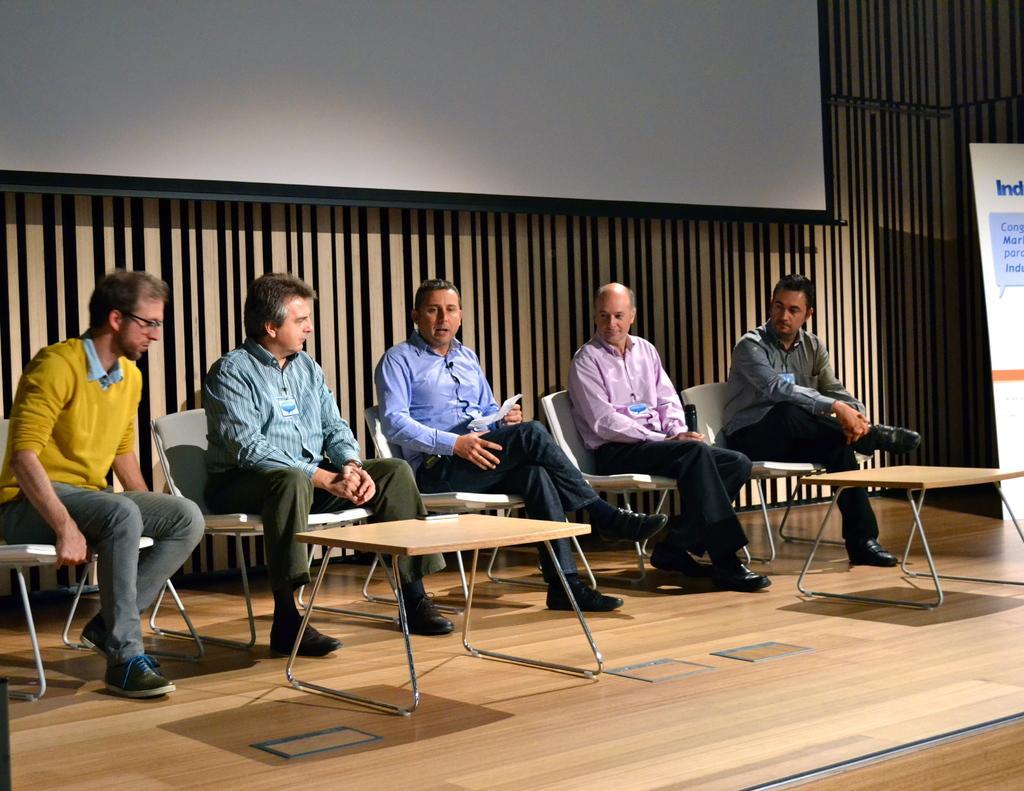Describe this image in one or two sentences. In this image, there are five persons wearing clothes and sitting on chairs in front of tables. There is a screen at the top of the image. There is a banner on the right side of the image. 